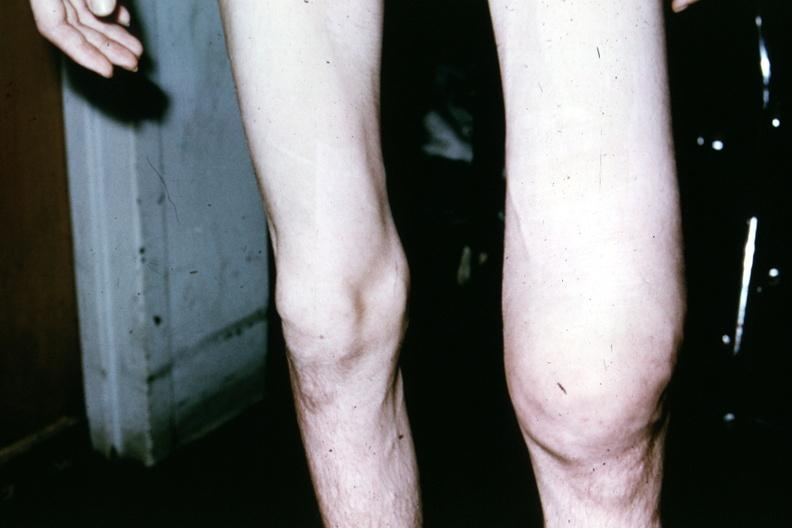when does this image show patient?
Answer the question using a single word or phrase. Before surgery showing both knees 18yo male 